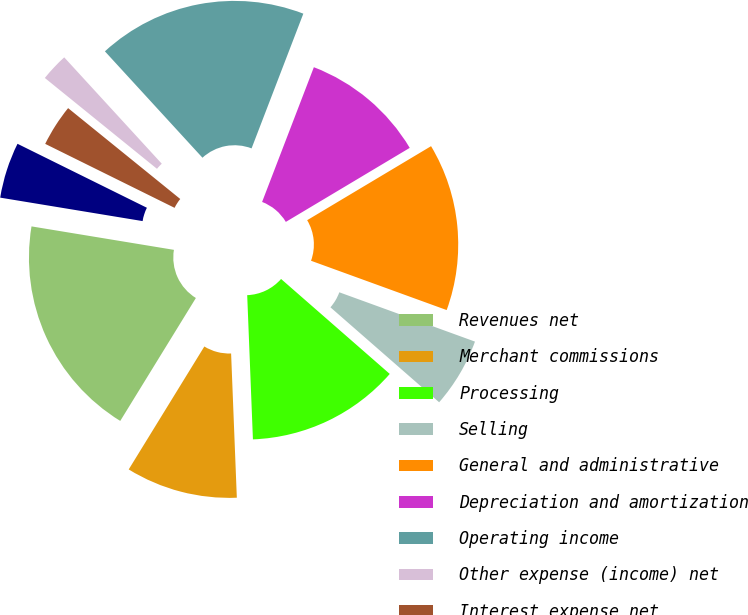Convert chart to OTSL. <chart><loc_0><loc_0><loc_500><loc_500><pie_chart><fcel>Revenues net<fcel>Merchant commissions<fcel>Processing<fcel>Selling<fcel>General and administrative<fcel>Depreciation and amortization<fcel>Operating income<fcel>Other expense (income) net<fcel>Interest expense net<fcel>Total other expense<nl><fcel>18.82%<fcel>9.41%<fcel>12.94%<fcel>5.88%<fcel>14.12%<fcel>10.59%<fcel>17.65%<fcel>2.35%<fcel>3.53%<fcel>4.71%<nl></chart> 